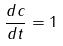<formula> <loc_0><loc_0><loc_500><loc_500>\frac { d c } { d t } = 1</formula> 